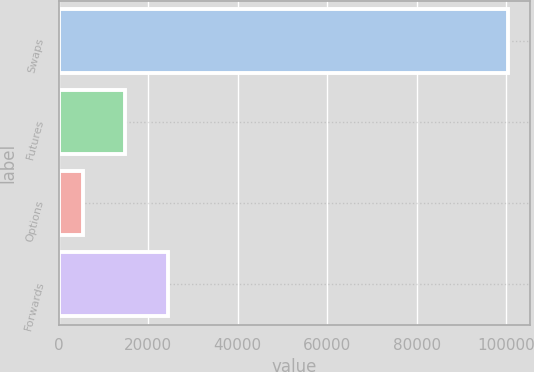<chart> <loc_0><loc_0><loc_500><loc_500><bar_chart><fcel>Swaps<fcel>Futures<fcel>Options<fcel>Forwards<nl><fcel>100331<fcel>14867<fcel>5371<fcel>24363<nl></chart> 